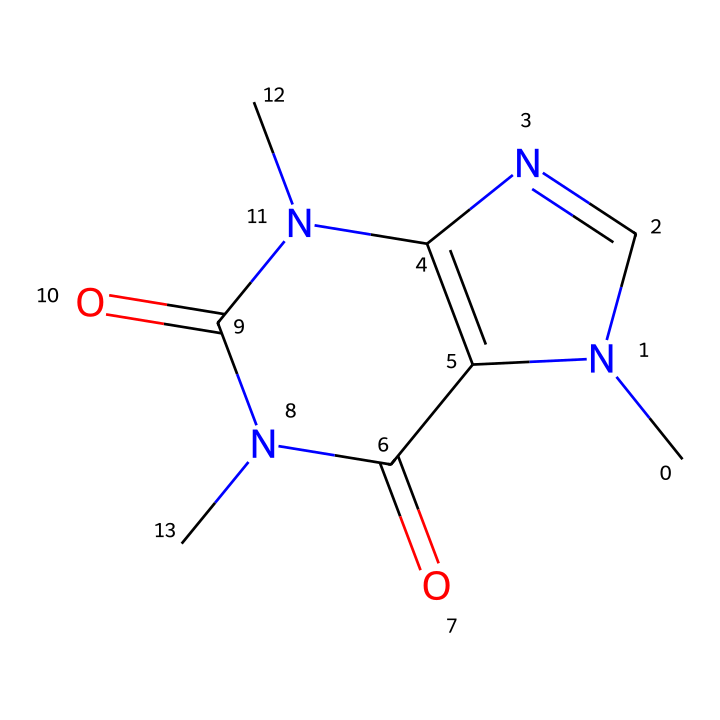What is the molecular formula of caffeine? To determine the molecular formula, we need to count the atoms of each element in the SMILES representation. The chemical structure displays carbon (C), hydrogen (H), nitrogen (N), and oxygen (O) atoms. By analyzing the structure, we find there are eight carbon atoms, ten hydrogen atoms, four nitrogen atoms, and two oxygen atoms. Therefore, the molecular formula is C8H10N4O2.
Answer: C8H10N4O2 How many rings are present in the structure of caffeine? By studying the SMILES representation, we note that the presence of 'N1', 'C2', and matching parenthesis indicates cyclic structures. Caffeine contains two fused rings based on its visual representation.
Answer: 2 What type of functional groups are present in caffeine? To identify functional groups, we analyze the structure for specific arrangements of atoms. The nitrogen atoms within the rings and the carbonyl groups (C=O) are key identifiers. Caffeine has amine groups (due to nitrogen) and keto groups (due to carbonyl), which are typical functional groups seen in such structures.
Answer: amine and keto groups Which atoms in caffeine are responsible for its psychoactive effects? Caffeine's psychoactive effects are primarily attributed to its nitrogen atoms. These atoms play a crucial role in its binding to adenosine receptors in the brain, which influences neural activity and alertness.
Answer: nitrogen atoms What is the role of caffeine in neural pathways? Caffeine acts as an antagonist to adenosine receptors within the neural pathways. This antagonistic action leads to increased neuronal firing and the release of neurotransmitters such as dopamine, promoting wakefulness and alertness.
Answer: antagonist to adenosine receptors 